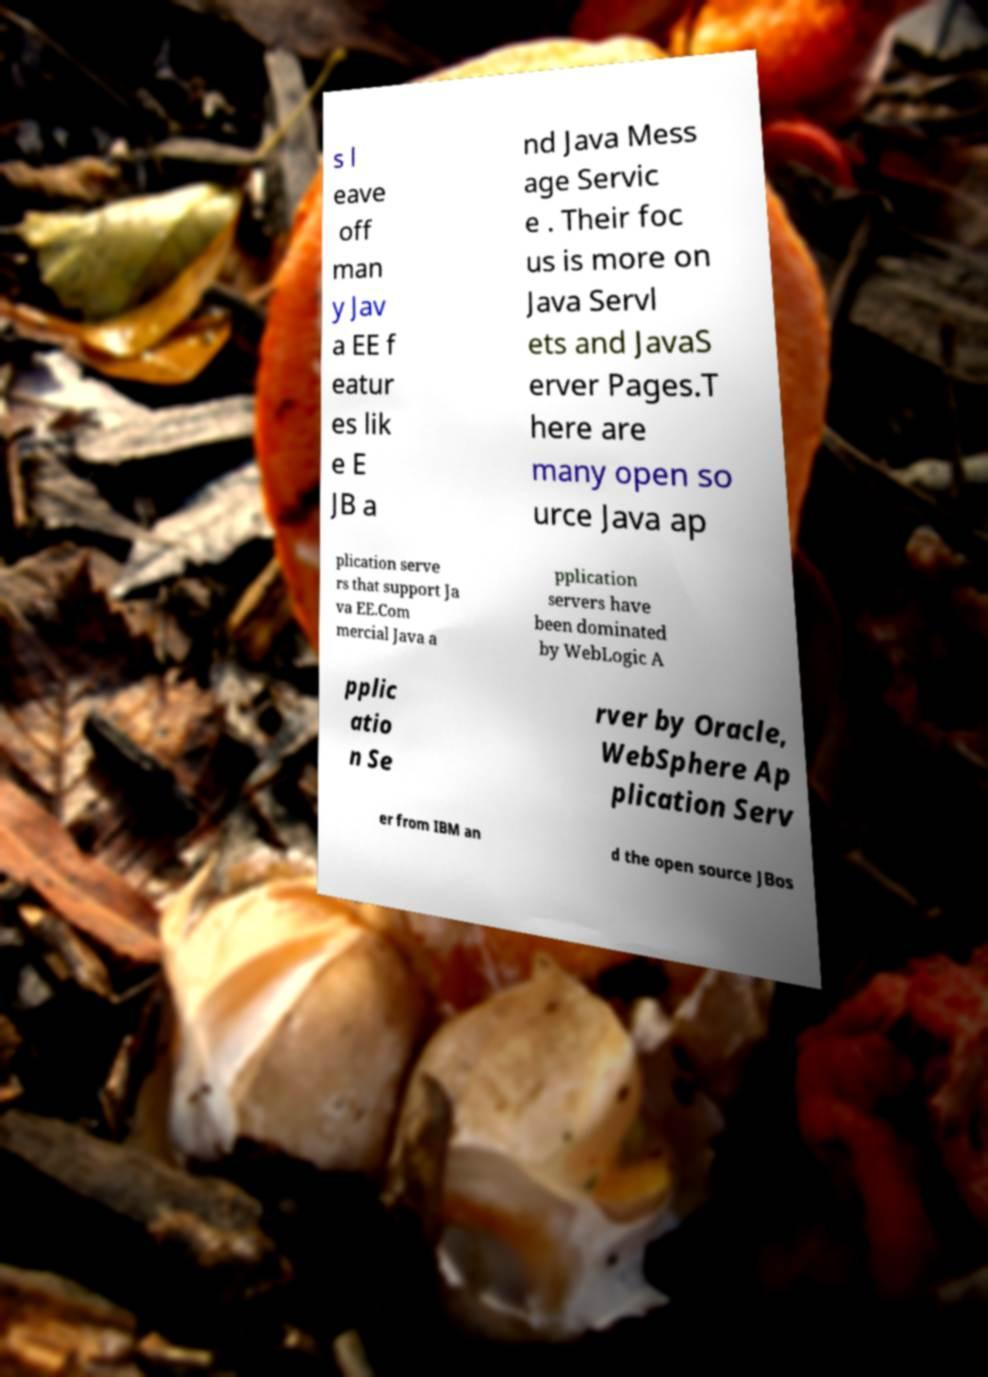Can you accurately transcribe the text from the provided image for me? s l eave off man y Jav a EE f eatur es lik e E JB a nd Java Mess age Servic e . Their foc us is more on Java Servl ets and JavaS erver Pages.T here are many open so urce Java ap plication serve rs that support Ja va EE.Com mercial Java a pplication servers have been dominated by WebLogic A pplic atio n Se rver by Oracle, WebSphere Ap plication Serv er from IBM an d the open source JBos 